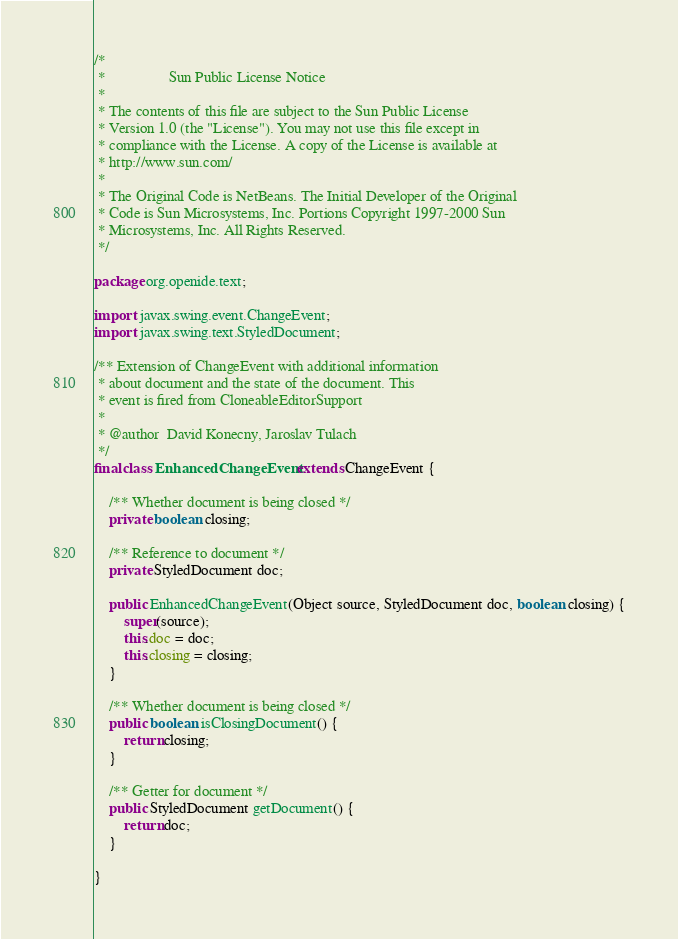Convert code to text. <code><loc_0><loc_0><loc_500><loc_500><_Java_>/*
 *                 Sun Public License Notice
 * 
 * The contents of this file are subject to the Sun Public License
 * Version 1.0 (the "License"). You may not use this file except in
 * compliance with the License. A copy of the License is available at
 * http://www.sun.com/
 * 
 * The Original Code is NetBeans. The Initial Developer of the Original
 * Code is Sun Microsystems, Inc. Portions Copyright 1997-2000 Sun
 * Microsystems, Inc. All Rights Reserved.
 */

package org.openide.text;

import javax.swing.event.ChangeEvent;
import javax.swing.text.StyledDocument;

/** Extension of ChangeEvent with additional information
 * about document and the state of the document. This
 * event is fired from CloneableEditorSupport
 *
 * @author  David Konecny, Jaroslav Tulach
 */
final class EnhancedChangeEvent extends ChangeEvent {

    /** Whether document is being closed */
    private boolean closing;
    
    /** Reference to document */
    private StyledDocument doc;

    public EnhancedChangeEvent(Object source, StyledDocument doc, boolean closing) {
        super(source);
        this.doc = doc;
        this.closing = closing;
    }
    
    /** Whether document is being closed */
    public boolean isClosingDocument() {
        return closing;
    }
    
    /** Getter for document */
    public StyledDocument getDocument() {
        return doc;
    }
    
}
</code> 